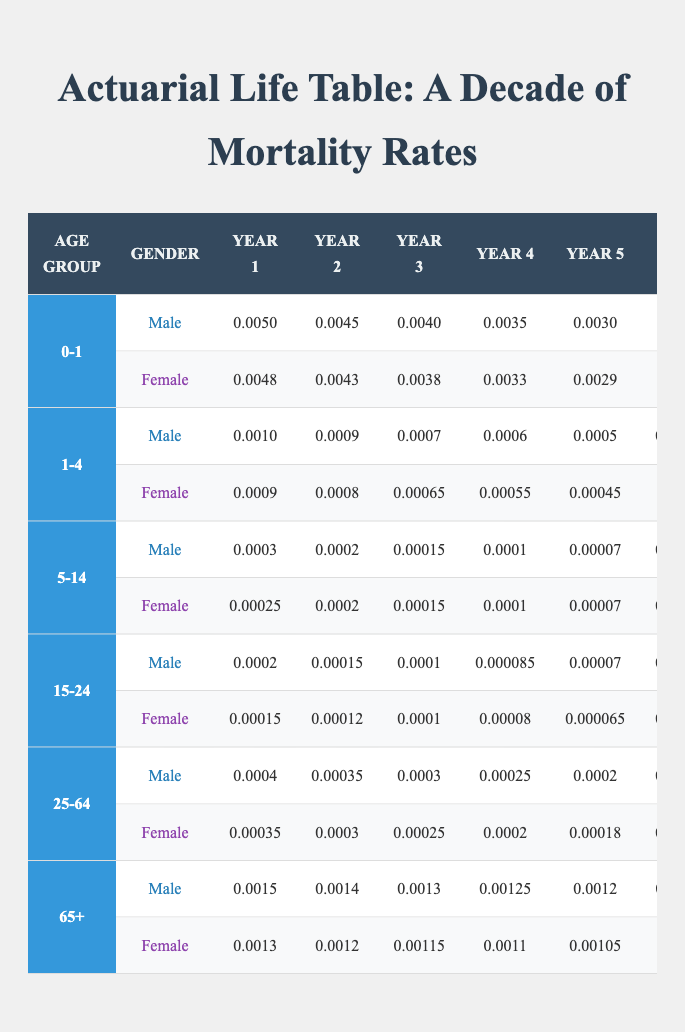What is the mortality rate for males in the 0-1 age group during year 5? Referring to the table, the mortality rate for males in the 0-1 age group for year 5 is indicated in the column for year 5 under the male row of that age group, which is 0.0030.
Answer: 0.0030 What is the mortality rate for females in the 15-24 age group during year 10? Looking at the table, the mortality rate for females in the 15-24 age group for year 10 is found in the corresponding female row under that age group, which reads as 0.00003.
Answer: 0.00003 Is the mortality rate for males in the 5-14 age group lower in year 3 compared to year 6? In the table, for males in the 5-14 age group, the mortality rate in year 3 is 0.00015 and in year 6 it is 0.00005. Since 0.00015 is greater than 0.00005, the statement is false.
Answer: No What is the difference between the mortality rates of females in the 25-64 age group for year 1 and year 10? The mortality rate for females in the 25-64 age group for year 1 is 0.00035, and for year 10, it is 0.00008. The difference can be calculated as 0.00035 - 0.00008 = 0.00027.
Answer: 0.00027 What is the average mortality rate for males in the 65+ age group over the ten years? To find the average, we need to sum the yearly rates for males in the 65+ age group and divide by the number of years. The rates are 0.0015, 0.0014, 0.0013, 0.00125, 0.0012, 0.00115, 0.0011, 0.001, 0.00095, and 0.0009. The total is 0.012025, and dividing by 10 gives an average of 0.0012025.
Answer: 0.0012025 What is the lowest mortality rate recorded for females across all age groups in year 9? After checking all the female mortality rates for year 9 from each age group, the lowest is found in the 5-14 age group with a rate of 0.00003, which is less than the others.
Answer: 0.00003 Are mortality rates for both genders in the 1-4 age group higher than in the 5-14 age group for year 1? For year 1, the male mortality rate in the 1-4 age group is 0.0010, which is higher than the male rate in the 5-14 age group at 0.0003. For females, it is 0.0009 versus 0.00025, confirming both are higher.
Answer: Yes What is the trend in male mortality rates for the 25-64 age group over the decade? Analyzing each year's rates for males in the 25-64 age group, we see a decreasing trend: 0.0004, 0.00035, 0.0003, 0.00025, 0.0002, 0.00018, 0.00015, 0.00012, 0.0001, and finally 0.00009. This indicates that mortality rates have consistently declined over the decade.
Answer: Decreasing trend 